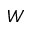Convert formula to latex. <formula><loc_0><loc_0><loc_500><loc_500>W</formula> 